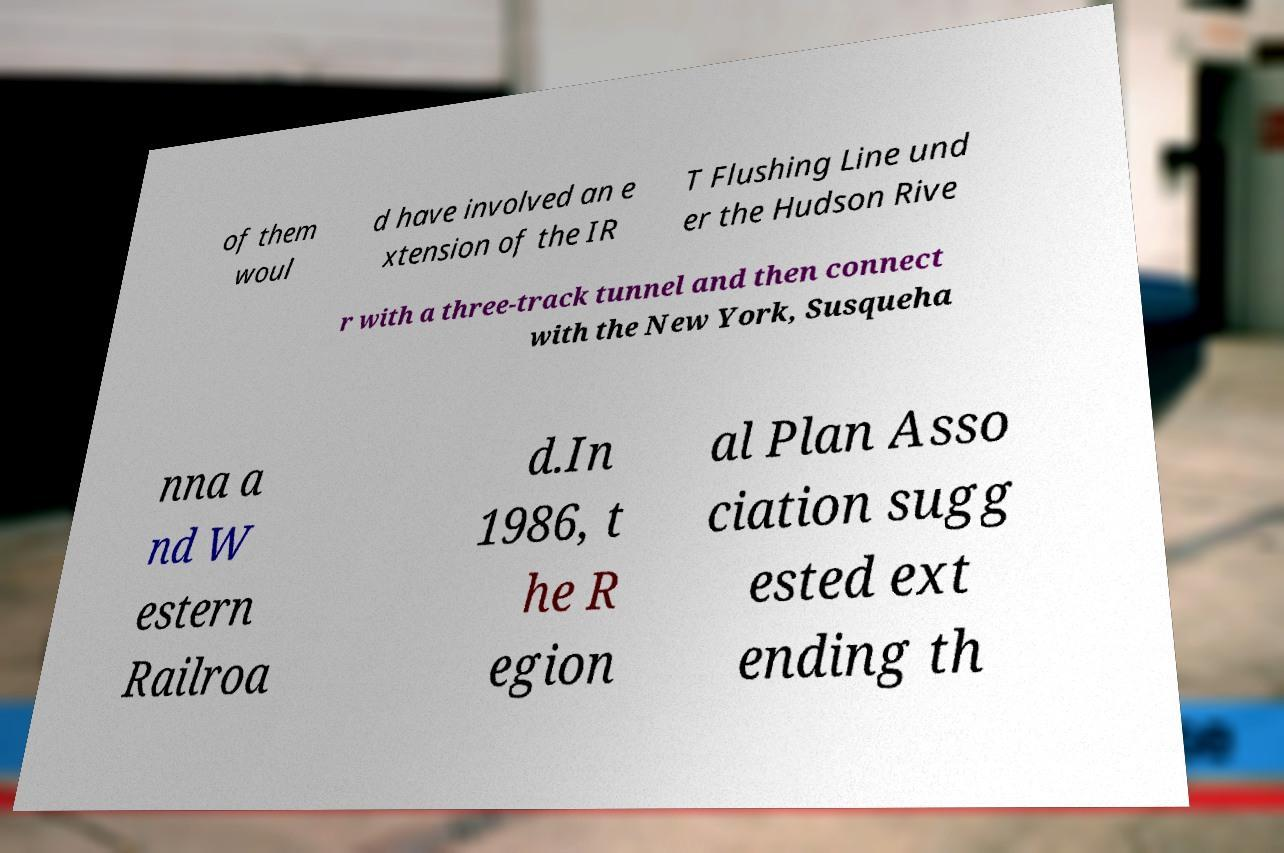Please identify and transcribe the text found in this image. of them woul d have involved an e xtension of the IR T Flushing Line und er the Hudson Rive r with a three-track tunnel and then connect with the New York, Susqueha nna a nd W estern Railroa d.In 1986, t he R egion al Plan Asso ciation sugg ested ext ending th 